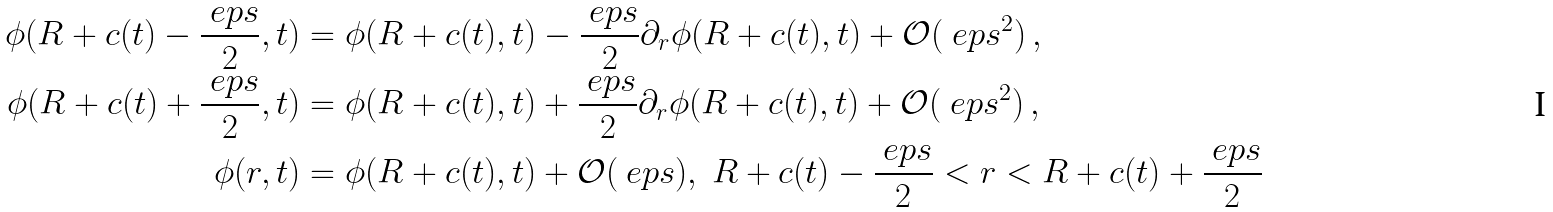<formula> <loc_0><loc_0><loc_500><loc_500>\phi ( R + c ( t ) - \frac { \ e p s } { 2 } , t ) & = \phi ( R + c ( t ) , t ) - \frac { \ e p s } { 2 } \partial _ { r } \phi ( R + c ( t ) , t ) + \mathcal { O } ( \ e p s ^ { 2 } ) \, , \\ \phi ( R + c ( t ) + \frac { \ e p s } { 2 } , t ) & = \phi ( R + c ( t ) , t ) + \frac { \ e p s } { 2 } \partial _ { r } \phi ( R + c ( t ) , t ) + \mathcal { O } ( \ e p s ^ { 2 } ) \, , \\ \phi ( r , t ) & = \phi ( R + c ( t ) , t ) + \mathcal { O } ( \ e p s ) , \ R + c ( t ) - \frac { \ e p s } { 2 } < r < R + c ( t ) + \frac { \ e p s } { 2 }</formula> 